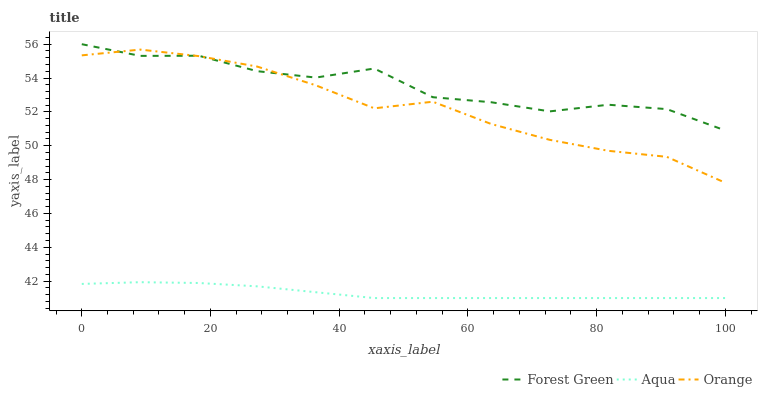Does Aqua have the minimum area under the curve?
Answer yes or no. Yes. Does Forest Green have the maximum area under the curve?
Answer yes or no. Yes. Does Forest Green have the minimum area under the curve?
Answer yes or no. No. Does Aqua have the maximum area under the curve?
Answer yes or no. No. Is Aqua the smoothest?
Answer yes or no. Yes. Is Forest Green the roughest?
Answer yes or no. Yes. Is Forest Green the smoothest?
Answer yes or no. No. Is Aqua the roughest?
Answer yes or no. No. Does Aqua have the lowest value?
Answer yes or no. Yes. Does Forest Green have the lowest value?
Answer yes or no. No. Does Forest Green have the highest value?
Answer yes or no. Yes. Does Aqua have the highest value?
Answer yes or no. No. Is Aqua less than Forest Green?
Answer yes or no. Yes. Is Forest Green greater than Aqua?
Answer yes or no. Yes. Does Orange intersect Forest Green?
Answer yes or no. Yes. Is Orange less than Forest Green?
Answer yes or no. No. Is Orange greater than Forest Green?
Answer yes or no. No. Does Aqua intersect Forest Green?
Answer yes or no. No. 